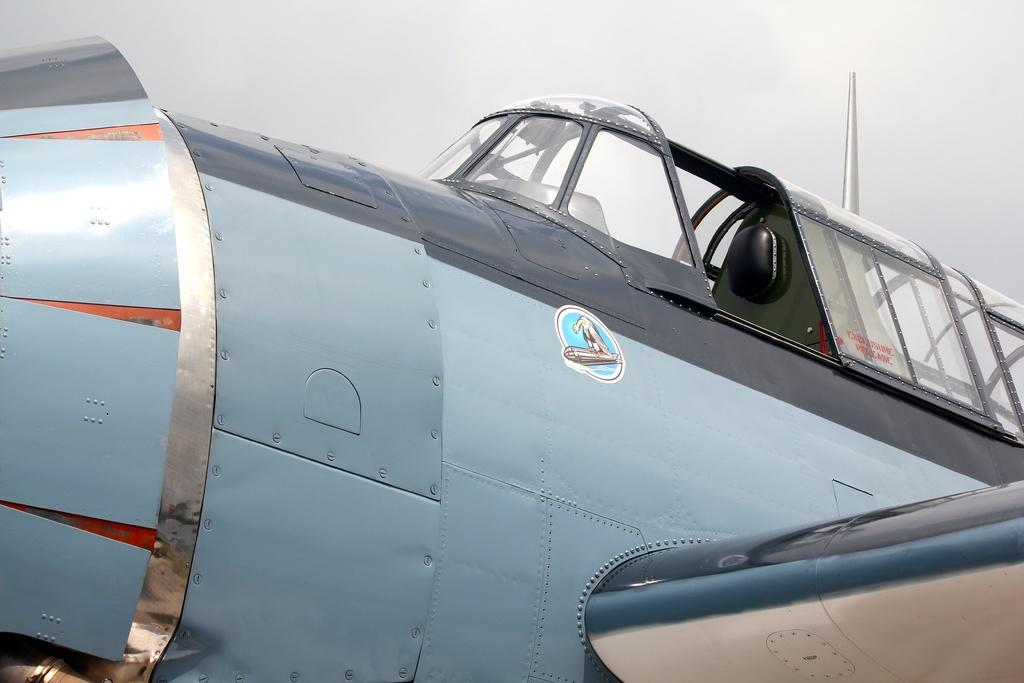What is the main subject of the picture? The main subject of the picture is an aircraft. Are there any additional features on the aircraft? Yes, there is a sticker and text on the aircraft. What is visible at the top of the image? The sky is visible at the top of the image. What type of teeth can be seen on the aircraft in the image? There are no teeth present on the aircraft in the image. Can you tell me the story behind the sticker on the aircraft? There is no information provided about the story behind the sticker on the aircraft, so it cannot be determined from the image. 